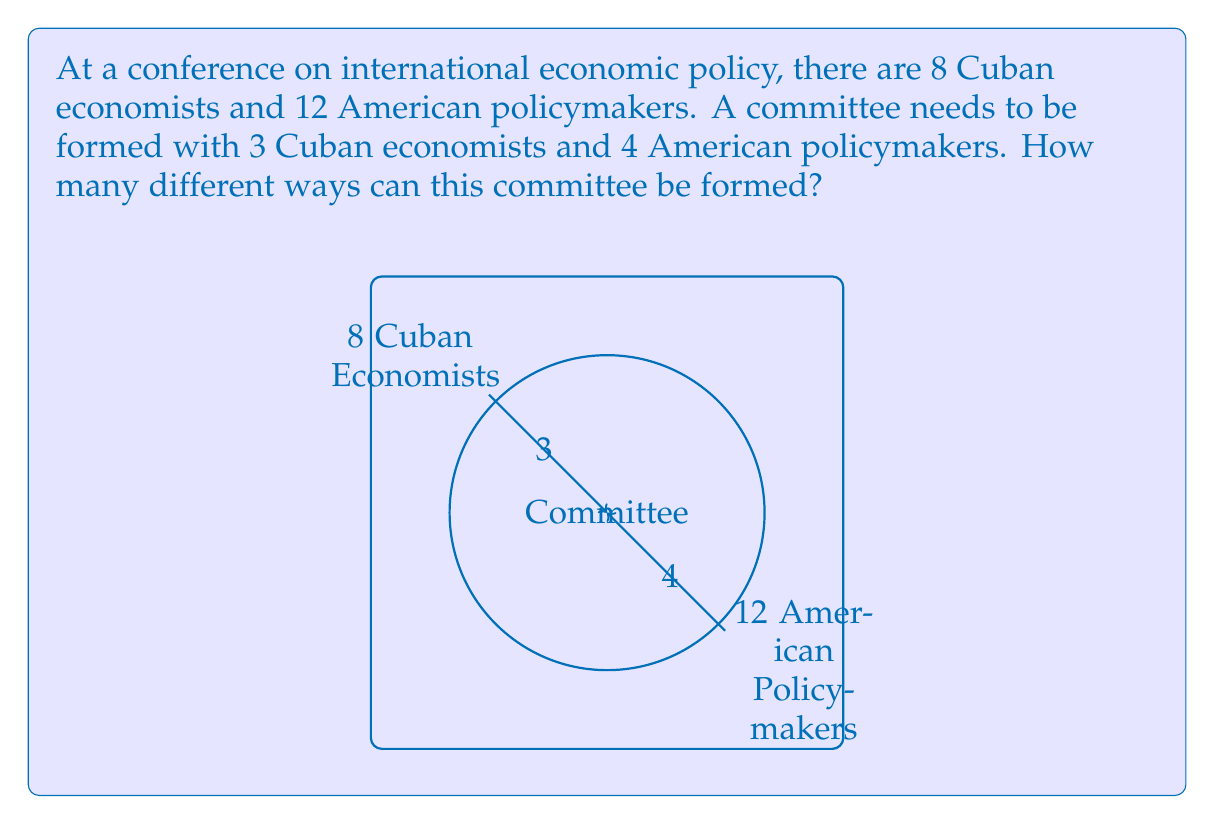What is the answer to this math problem? Let's approach this step-by-step using the multiplication principle of counting:

1) First, we need to choose 3 Cuban economists from 8. This can be done in $\binom{8}{3}$ ways.

2) Then, we need to choose 4 American policymakers from 12. This can be done in $\binom{12}{4}$ ways.

3) The combination formula is:

   $$\binom{n}{k} = \frac{n!}{k!(n-k)!}$$

4) For the Cuban economists:
   $$\binom{8}{3} = \frac{8!}{3!(8-3)!} = \frac{8!}{3!5!} = 56$$

5) For the American policymakers:
   $$\binom{12}{4} = \frac{12!}{4!(12-4)!} = \frac{12!}{4!8!} = 495$$

6) By the multiplication principle, the total number of ways to form the committee is:

   $$56 \times 495 = 27,720$$

Therefore, there are 27,720 different ways to form this committee.
Answer: 27,720 